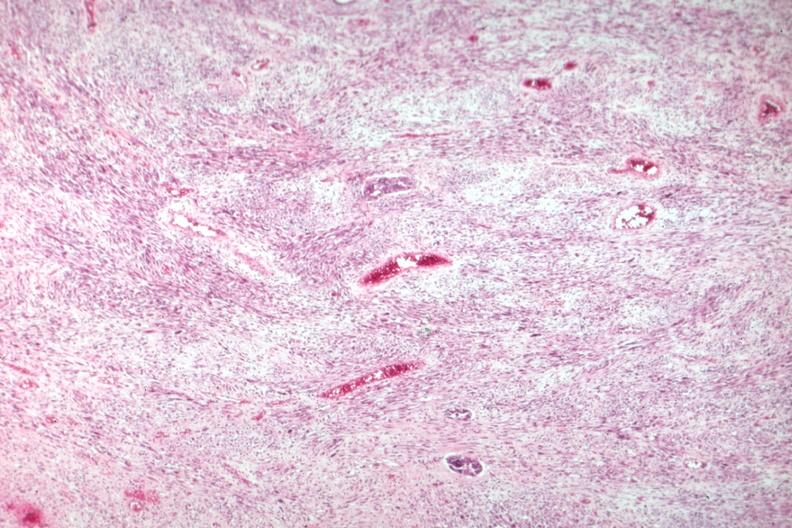s simian crease present?
Answer the question using a single word or phrase. No 